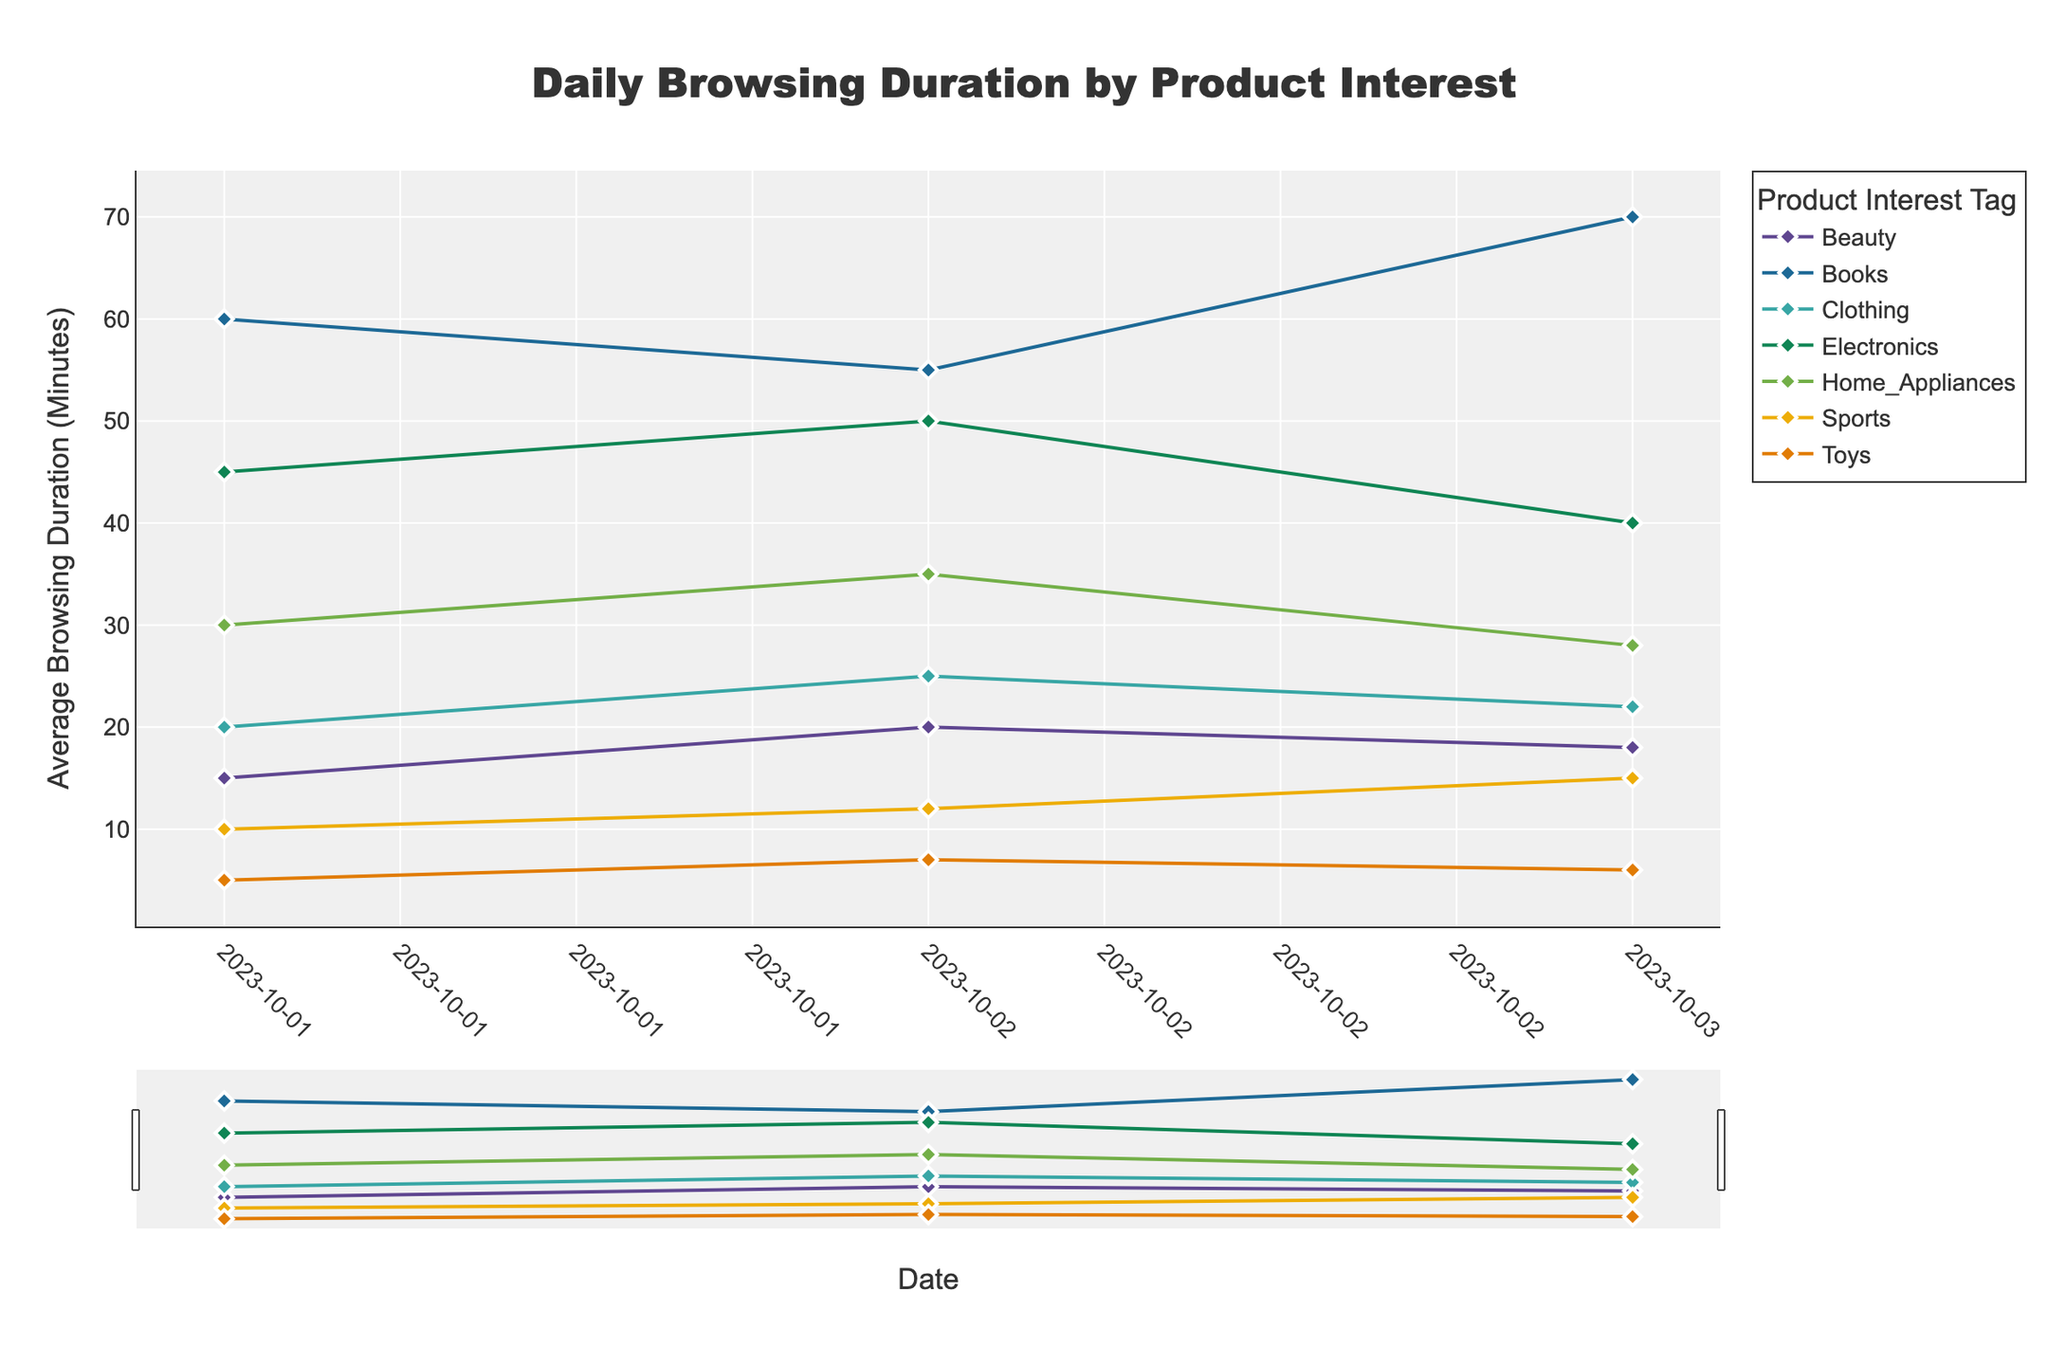What's the title of the figure? The title is usually placed at the top and summarizes what the plot represents. In this case, it reads "Daily Browsing Duration by Product Interest".
Answer: Daily Browsing Duration by Product Interest What are the labels for the x-axis and y-axis? The x-axis and y-axis labels are found along the horizontal and vertical axes respectively, indicating the type of data being plotted. For this figure, the x-axis is labeled "Date" and the y-axis is labeled "Average Browsing Duration (Minutes)".
Answer: Date, Average Browsing Duration (Minutes) How many product interest tags are shown in the plot? Each line in the time series plot represents a different product interest tag, which can be identified by the legend. Counting the unique entries will give the number of tags. There are seven tags: Electronics, Home Appliances, Books, Clothing, Beauty, Sports, and Toys.
Answer: 7 Which product interest tag had the highest average browsing duration on October 3, 2023? To determine this, you should locate October 3, 2023, on the x-axis and observe which line reaches the highest point for that date. The tag associated with that line is Books.
Answer: Books What is the color of the line representing "Sports"? The color for each product interest tag is depicted in the legend. According to the legend, the line for "Sports" is the second to last color in the Prism color scheme provided. It's green in this specific plot.
Answer: Green Compare the browsing duration trends of "Electronics" and "Clothing" over the three days. To compare trends, observe the patterns of the lines representing "Electronics" and "Clothing". "Electronics" starts at a high value on October 1st, increases on October 2nd, and then decreases on October 3rd. On the other hand, "Clothing" starts at a lower value, slightly increases on October 2nd, and remains nearly flat on October 3rd with minor fluctuation.
Answer: Electronics: Decreases then increases; Clothing: Slight rise and flat Which day had the lowest average browsing duration for the "Beauty" interest tag? By finding the "Beauty" line in the plot, we can see which day has the lowest point on that line. The lowest average browsing duration for "Beauty" was on October 1, 2023.
Answer: October 1, 2023 What is the average browsing duration across all product interest tags on October 2, 2023? First, find the average browsing duration for each product interest tag on October 2, 2023, from the plot: Electronics (50), Home Appliances (35), Books (55), Clothing (25), Beauty (20), Sports (12), and Toys (7). Then sum these durations and divide by the number of tags. The calculation is (50+35+55+25+20+12+7)/7 = 204/7 = 29.1 minutes.
Answer: 29.1 minutes Which product interest tag shows the least fluctuation in browsing duration over the three days? To determine which tag fluctuates the least, look for the line that remains the most stable in height over the three days. The "Clothing" tag shows the least fluctuation in browsing duration.
Answer: Clothing 